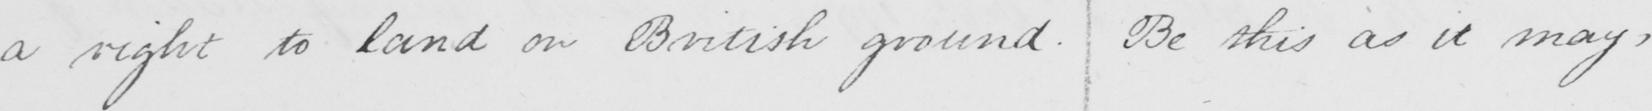Please transcribe the handwritten text in this image. a right to land on British ground . Be this as it may , 